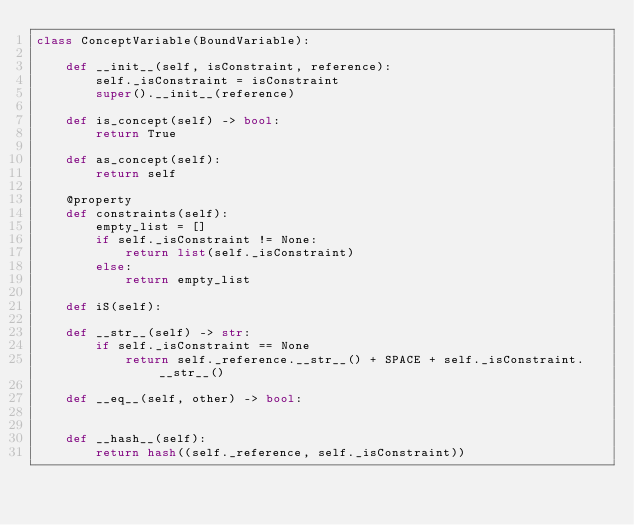Convert code to text. <code><loc_0><loc_0><loc_500><loc_500><_Python_>class ConceptVariable(BoundVariable):

    def __init__(self, isConstraint, reference):
        self._isConstraint = isConstraint
        super().__init__(reference)
    
    def is_concept(self) -> bool:
        return True
    
    def as_concept(self):
        return self
    
    @property
    def constraints(self):
        empty_list = []
        if self._isConstraint != None:
            return list(self._isConstraint)
        else:
            return empty_list

    def iS(self):

    def __str__(self) -> str:
        if self._isConstraint == None
            return self._reference.__str__() + SPACE + self._isConstraint.__str__()

    def __eq__(self, other) -> bool:

    
    def __hash__(self):
        return hash((self._reference, self._isConstraint))
</code> 